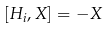Convert formula to latex. <formula><loc_0><loc_0><loc_500><loc_500>[ H _ { i } , X ] = - X</formula> 